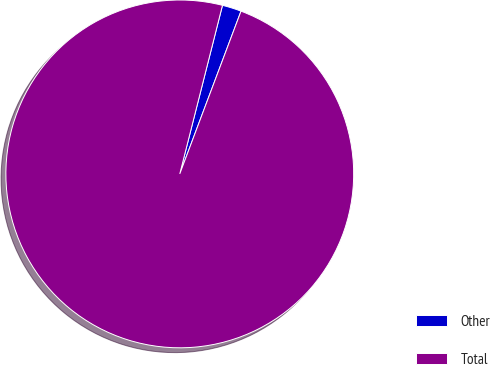<chart> <loc_0><loc_0><loc_500><loc_500><pie_chart><fcel>Other<fcel>Total<nl><fcel>1.78%<fcel>98.22%<nl></chart> 